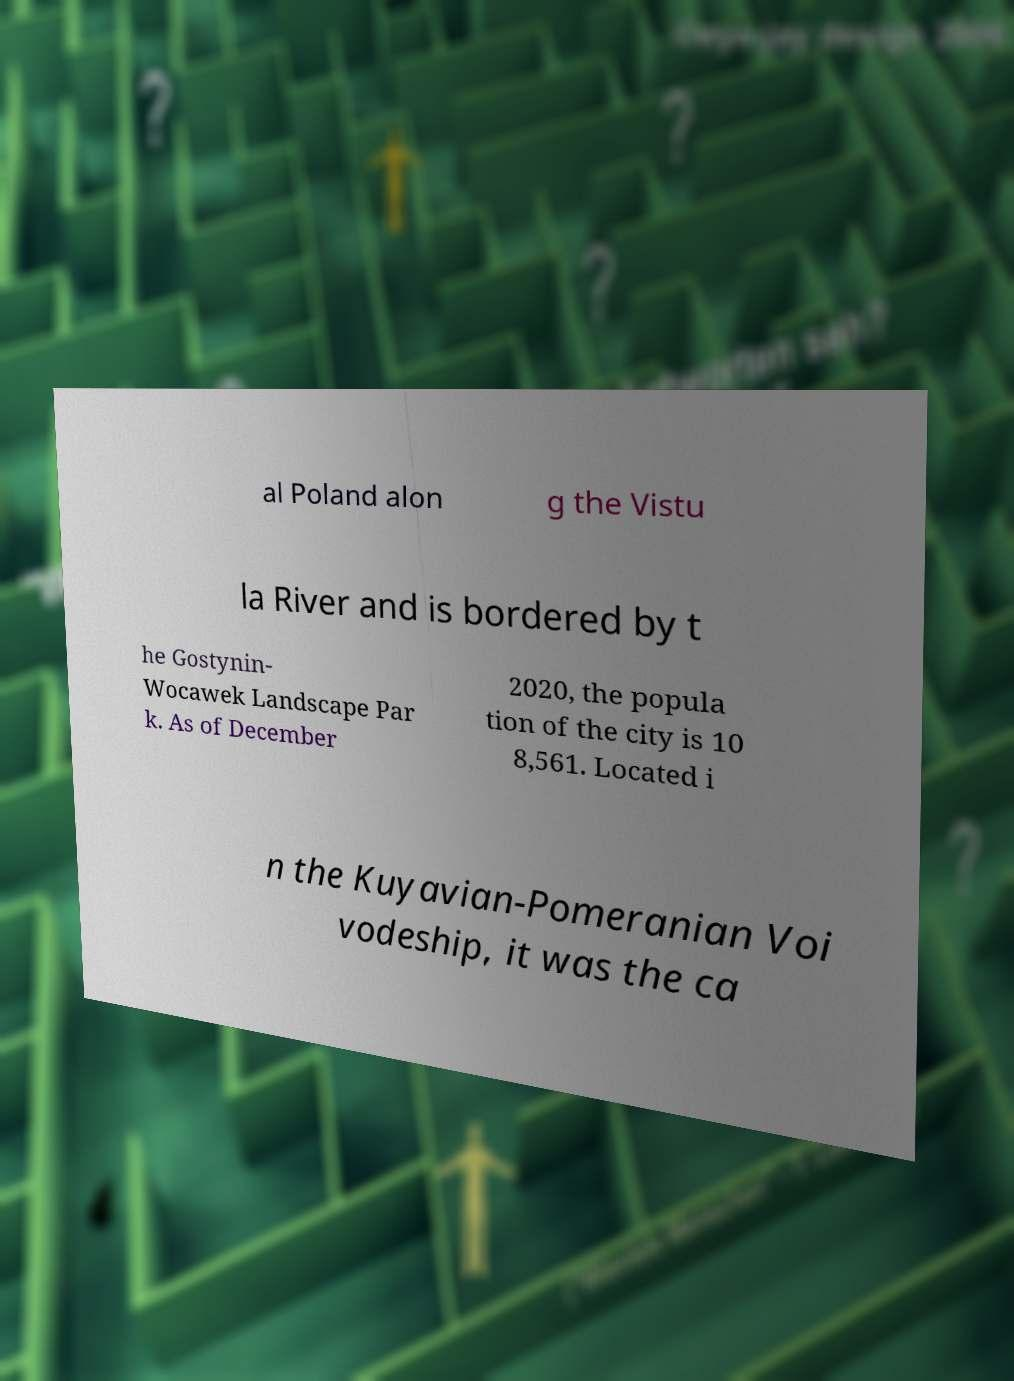Can you accurately transcribe the text from the provided image for me? al Poland alon g the Vistu la River and is bordered by t he Gostynin- Wocawek Landscape Par k. As of December 2020, the popula tion of the city is 10 8,561. Located i n the Kuyavian-Pomeranian Voi vodeship, it was the ca 